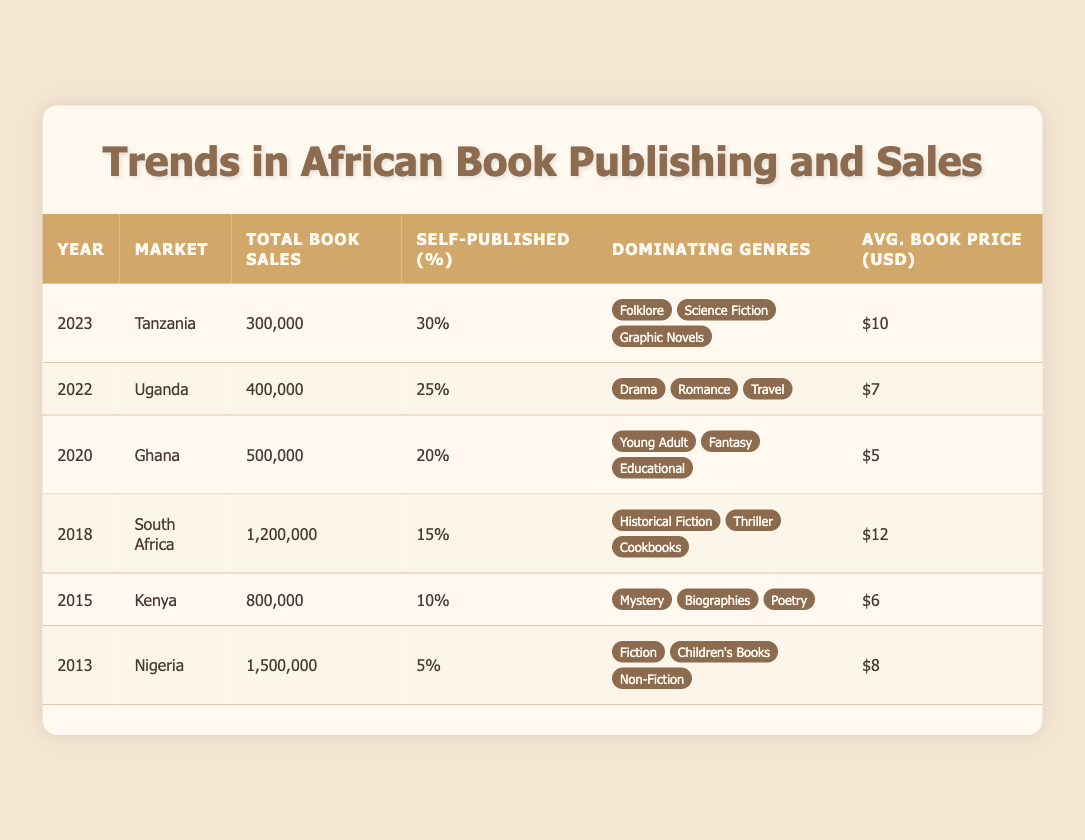What was the total book sales in Nigeria in 2013? The table indicates that in 2013, the total book sales in Nigeria were listed as 1,500,000 units.
Answer: 1,500,000 Which country had the highest average book price and what was that price? The table shows that South Africa had the highest average book price at $12.
Answer: $12 and South Africa How much did self-published books constitute in total sales in Uganda in 2022? Uganda in 2022 had a total of 400,000 book sales, and the self-published percentage was 25%. Calculating this gives 25% of 400,000, which equals 100,000.
Answer: 100,000 Is it true that the percentage of self-published books increased from 2013 to 2023? Referring to the table, in 2013, the self-published percentage in Nigeria was 5%, and by 2023, it increased to 30% in Tanzania. Therefore, the statement is true.
Answer: Yes What is the total number of book sales across all markets in the year 2018? The only market listed for the year 2018 is South Africa with total book sales of 1,200,000. Thus, that is the total for that year.
Answer: 1,200,000 If we average the average book prices from 2013 to 2023, what do we get? The average prices are: $8 (Nigeria), $6 (Kenya), $12 (South Africa), $5 (Ghana), $7 (Uganda), and $10 (Tanzania). To find the average, sum these prices (8 + 6 + 12 + 5 + 7 + 10 = 48) and divide by the number of prices (6). Therefore, 48/6 = 8.
Answer: 8 In which year did Ghana have the lowest total book sales? The table shows that Ghana had a total of 500,000 book sales in 2020, which is less than any figures for other given years and countries listed.
Answer: 2020 Which genre dominated sales in both Tanzania (2023) and Uganda (2022)? The genres listed for Tanzania are Folklore, Science Fiction, and Graphic Novels for 2023, while Uganda’s dominating genres are Drama, Romance, and Travel for 2022. There are no overlapping genres between these two markets, so the answer is none.
Answer: None 